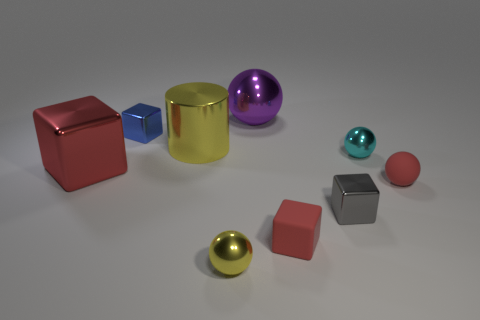Does the tiny red thing that is on the left side of the gray shiny block have the same material as the small sphere that is behind the red sphere?
Your response must be concise. No. What is the size of the red thing that is on the left side of the big cylinder?
Your answer should be compact. Large. There is a red thing that is the same shape as the tiny cyan thing; what is its material?
Keep it short and to the point. Rubber. Is there any other thing that is the same size as the yellow cylinder?
Keep it short and to the point. Yes. There is a small red matte thing that is behind the rubber block; what shape is it?
Your response must be concise. Sphere. How many tiny yellow things have the same shape as the red metal object?
Keep it short and to the point. 0. Are there the same number of tiny red objects that are behind the small gray thing and big yellow metallic cylinders that are on the right side of the tiny yellow metal ball?
Your answer should be compact. No. Are there any cyan objects that have the same material as the tiny red sphere?
Your answer should be compact. No. Are the yellow sphere and the tiny blue thing made of the same material?
Your response must be concise. Yes. How many blue objects are tiny balls or metal spheres?
Keep it short and to the point. 0. 